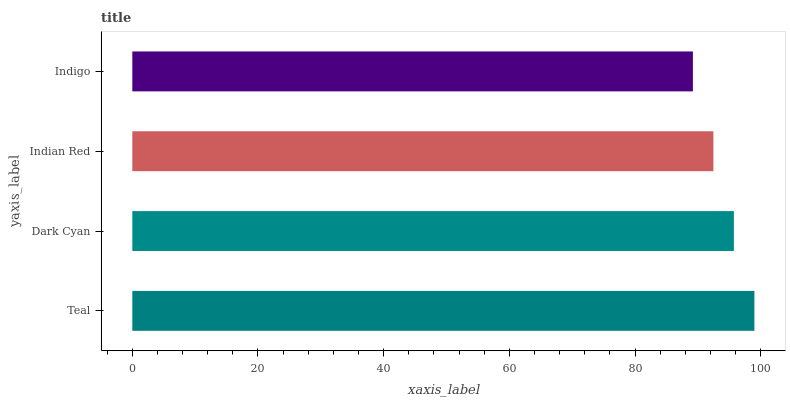Is Indigo the minimum?
Answer yes or no. Yes. Is Teal the maximum?
Answer yes or no. Yes. Is Dark Cyan the minimum?
Answer yes or no. No. Is Dark Cyan the maximum?
Answer yes or no. No. Is Teal greater than Dark Cyan?
Answer yes or no. Yes. Is Dark Cyan less than Teal?
Answer yes or no. Yes. Is Dark Cyan greater than Teal?
Answer yes or no. No. Is Teal less than Dark Cyan?
Answer yes or no. No. Is Dark Cyan the high median?
Answer yes or no. Yes. Is Indian Red the low median?
Answer yes or no. Yes. Is Teal the high median?
Answer yes or no. No. Is Dark Cyan the low median?
Answer yes or no. No. 